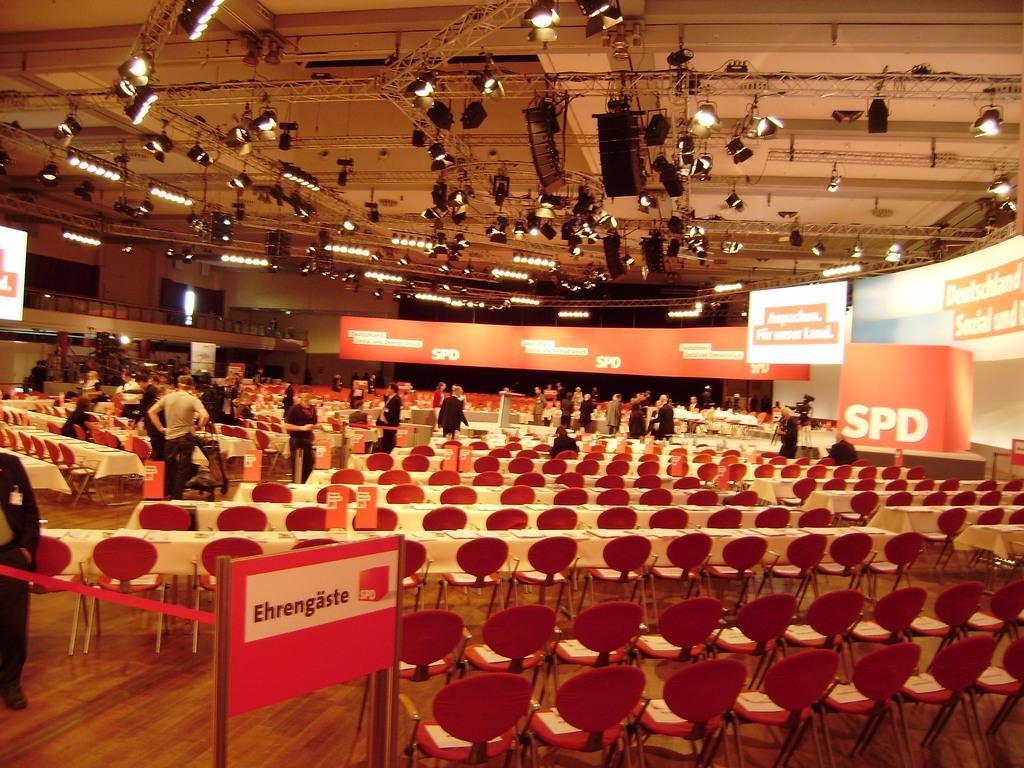Please provide a concise description of this image. In this image in the center there are some persons, and also i can see some chairs, boards, railing. And in the background there are some boards, on the boards there is text. At the top there are some towers, lights, ceiling and some other objects. And on the left side there is wall and some other objects, at the bottom there is floor. 